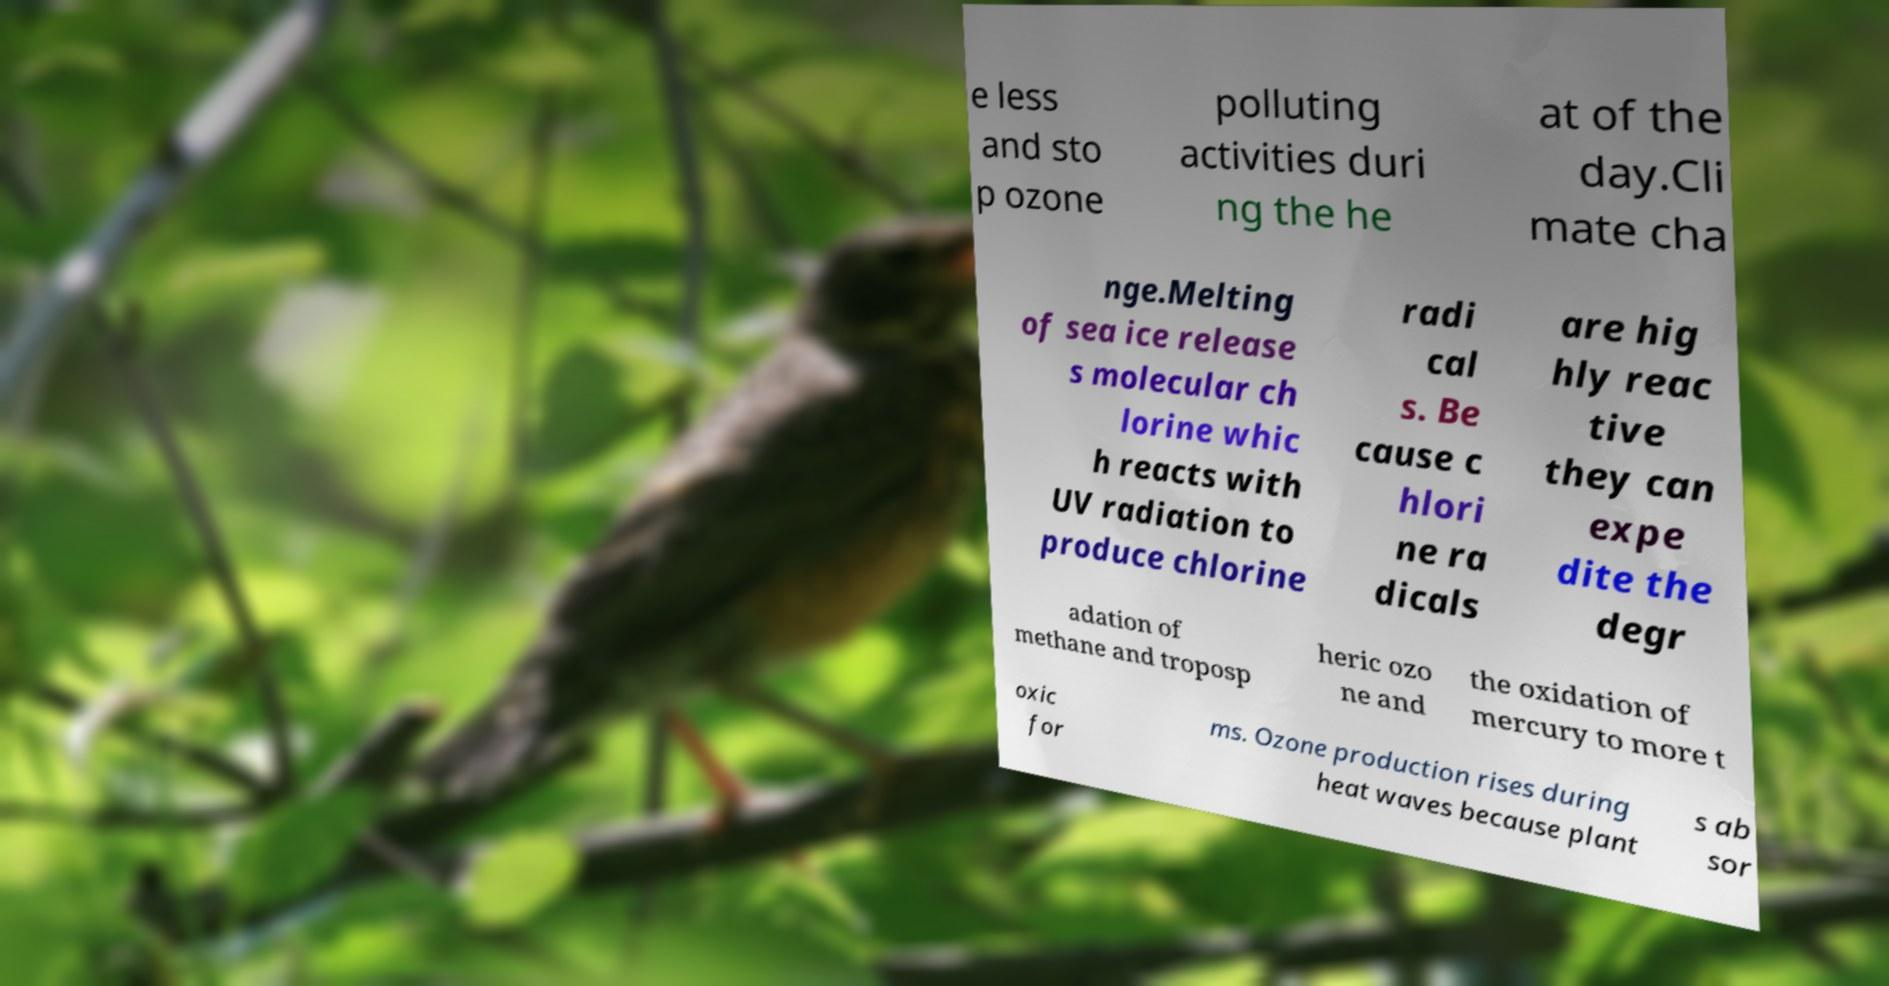Can you accurately transcribe the text from the provided image for me? e less and sto p ozone polluting activities duri ng the he at of the day.Cli mate cha nge.Melting of sea ice release s molecular ch lorine whic h reacts with UV radiation to produce chlorine radi cal s. Be cause c hlori ne ra dicals are hig hly reac tive they can expe dite the degr adation of methane and troposp heric ozo ne and the oxidation of mercury to more t oxic for ms. Ozone production rises during heat waves because plant s ab sor 